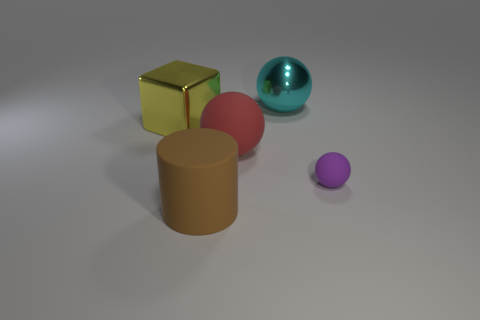Is there any other thing that is the same shape as the brown matte object?
Make the answer very short. No. What size is the other matte thing that is the same shape as the purple thing?
Ensure brevity in your answer.  Large. Are there more balls that are to the right of the big cyan sphere than big brown rubber objects that are behind the purple sphere?
Offer a very short reply. Yes. What is the big object that is in front of the large cube and behind the tiny sphere made of?
Ensure brevity in your answer.  Rubber. There is another shiny object that is the same shape as the big red thing; what color is it?
Offer a very short reply. Cyan. What is the size of the brown cylinder?
Give a very brief answer. Large. There is a sphere that is right of the large object that is behind the big yellow metal cube; what is its color?
Provide a succinct answer. Purple. How many objects are both behind the small matte object and in front of the large cyan metallic object?
Keep it short and to the point. 2. Is the number of big matte things greater than the number of big brown matte objects?
Your answer should be very brief. Yes. What is the purple sphere made of?
Keep it short and to the point. Rubber. 